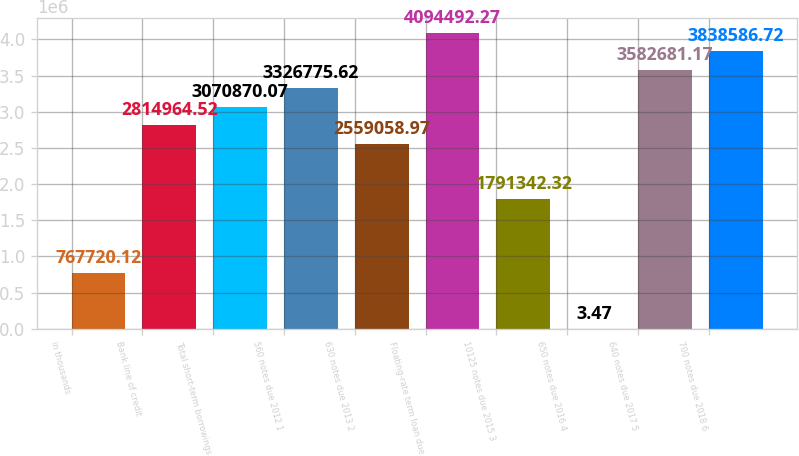<chart> <loc_0><loc_0><loc_500><loc_500><bar_chart><fcel>in thousands<fcel>Bank line of credit<fcel>Total short-term borrowings<fcel>560 notes due 2012 1<fcel>630 notes due 2013 2<fcel>Floating-rate term loan due<fcel>10125 notes due 2015 3<fcel>650 notes due 2016 4<fcel>640 notes due 2017 5<fcel>700 notes due 2018 6<nl><fcel>767720<fcel>2.81496e+06<fcel>3.07087e+06<fcel>3.32678e+06<fcel>2.55906e+06<fcel>4.09449e+06<fcel>1.79134e+06<fcel>3.47<fcel>3.58268e+06<fcel>3.83859e+06<nl></chart> 